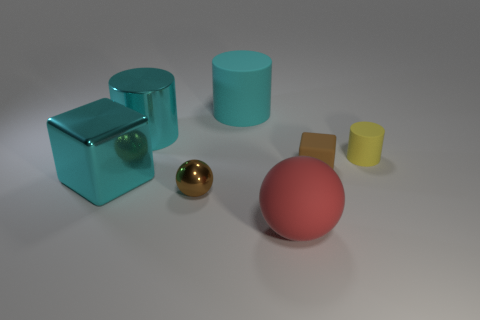Does the tiny rubber cube have the same color as the small object in front of the tiny cube?
Provide a short and direct response. Yes. Is the shiny cylinder the same color as the shiny block?
Give a very brief answer. Yes. There is a tiny object that is the same color as the small shiny sphere; what shape is it?
Provide a short and direct response. Cube. Is the number of big cyan rubber objects less than the number of small matte objects?
Offer a terse response. Yes. Are there any big rubber cylinders that are on the right side of the large rubber thing in front of the large metallic block?
Keep it short and to the point. No. There is a big cyan thing that is the same material as the red thing; what is its shape?
Your answer should be compact. Cylinder. Are there any other things that are the same color as the big sphere?
Offer a very short reply. No. What is the material of the small brown thing that is the same shape as the red matte thing?
Offer a very short reply. Metal. How many other objects are the same size as the red matte ball?
Keep it short and to the point. 3. There is another cylinder that is the same color as the large metallic cylinder; what size is it?
Your answer should be very brief. Large. 